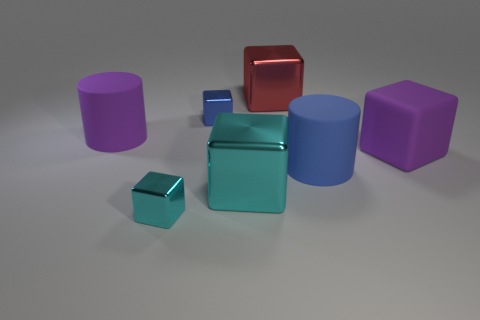Subtract all gray spheres. How many cyan cubes are left? 2 Subtract all small metal blocks. How many blocks are left? 3 Add 3 big matte cylinders. How many objects exist? 10 Subtract all cyan cubes. How many cubes are left? 3 Subtract 3 cubes. How many cubes are left? 2 Add 5 big objects. How many big objects are left? 10 Add 7 big purple blocks. How many big purple blocks exist? 8 Subtract 0 gray cylinders. How many objects are left? 7 Subtract all blocks. How many objects are left? 2 Subtract all red cylinders. Subtract all blue blocks. How many cylinders are left? 2 